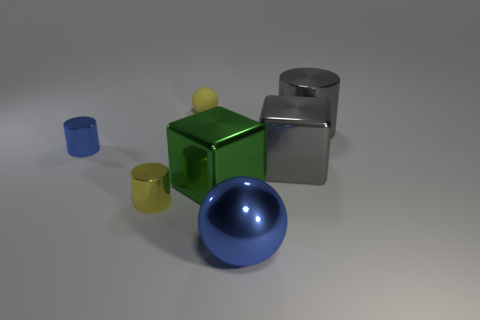What shape is the small thing that is the same color as the metallic ball?
Make the answer very short. Cylinder. The small metal thing left of the yellow thing that is in front of the yellow rubber sphere is what shape?
Your response must be concise. Cylinder. What number of blue things are either small rubber spheres or large spheres?
Your answer should be very brief. 1. Are there any big metallic cylinders right of the gray cylinder?
Your response must be concise. No. What is the size of the gray cylinder?
Your answer should be very brief. Large. What is the size of the blue object that is the same shape as the yellow matte thing?
Provide a succinct answer. Large. How many yellow spheres are in front of the metallic cylinder that is right of the large gray cube?
Your answer should be compact. 0. Is the blue object right of the tiny yellow shiny thing made of the same material as the tiny yellow object that is behind the large gray metal cylinder?
Ensure brevity in your answer.  No. What number of small shiny things are the same shape as the small matte object?
Make the answer very short. 0. How many big cubes are the same color as the large cylinder?
Provide a short and direct response. 1. 